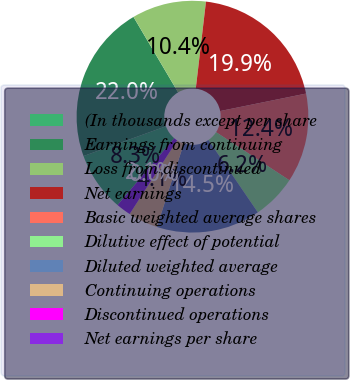Convert chart. <chart><loc_0><loc_0><loc_500><loc_500><pie_chart><fcel>(In thousands except per share<fcel>Earnings from continuing<fcel>Loss from discontinued<fcel>Net earnings<fcel>Basic weighted average shares<fcel>Dilutive effect of potential<fcel>Diluted weighted average<fcel>Continuing operations<fcel>Discontinued operations<fcel>Net earnings per share<nl><fcel>8.29%<fcel>22.02%<fcel>10.36%<fcel>19.95%<fcel>12.44%<fcel>6.22%<fcel>14.51%<fcel>4.15%<fcel>0.0%<fcel>2.07%<nl></chart> 